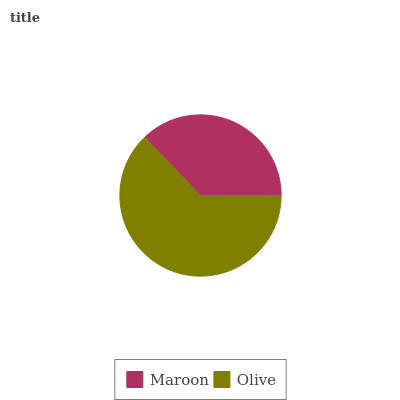Is Maroon the minimum?
Answer yes or no. Yes. Is Olive the maximum?
Answer yes or no. Yes. Is Olive the minimum?
Answer yes or no. No. Is Olive greater than Maroon?
Answer yes or no. Yes. Is Maroon less than Olive?
Answer yes or no. Yes. Is Maroon greater than Olive?
Answer yes or no. No. Is Olive less than Maroon?
Answer yes or no. No. Is Olive the high median?
Answer yes or no. Yes. Is Maroon the low median?
Answer yes or no. Yes. Is Maroon the high median?
Answer yes or no. No. Is Olive the low median?
Answer yes or no. No. 